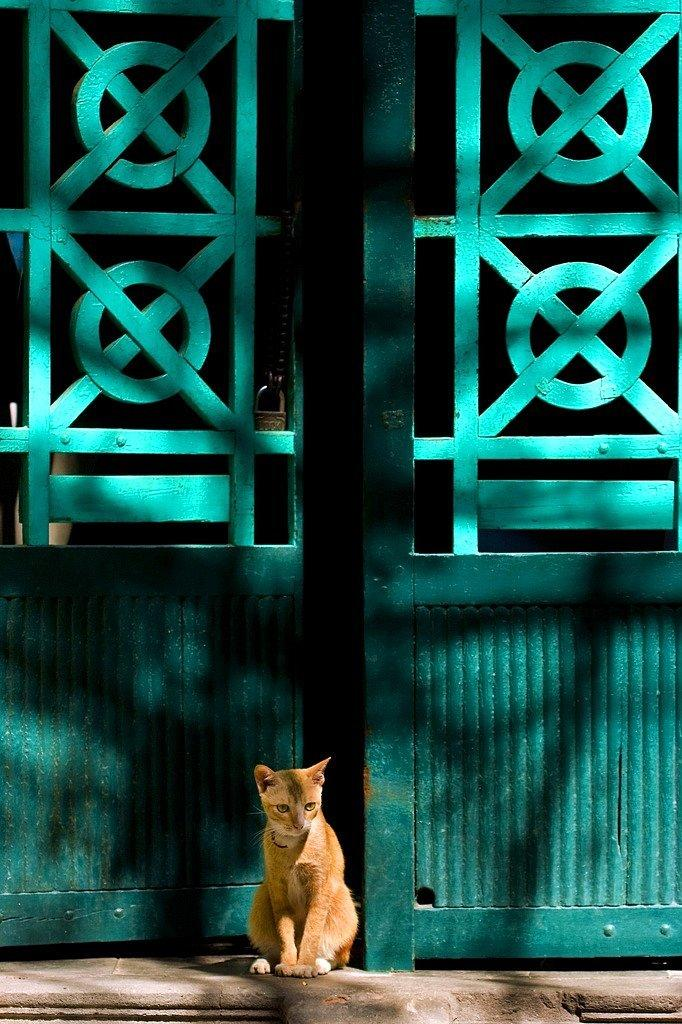What is the main subject in the center of the image? There is a cat in the center of the image. What can be seen behind the cat? There is a gate behind the cat. Is the gate secured in any way? Yes, the gate has a lock on it. What type of line is being used to measure the cat's heart rate in the image? There is no line or heart rate measurement present in the image; it features a cat and a locked gate. 